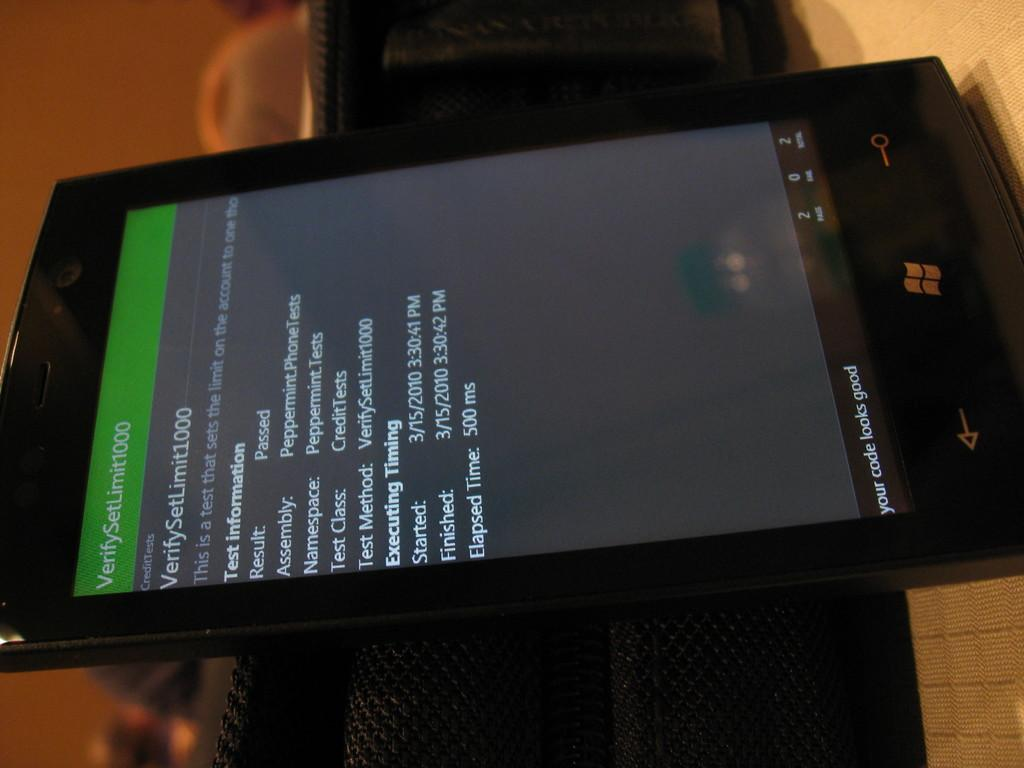<image>
Render a clear and concise summary of the photo. An electronic device open to a page that says VerifySetLimit1000. 